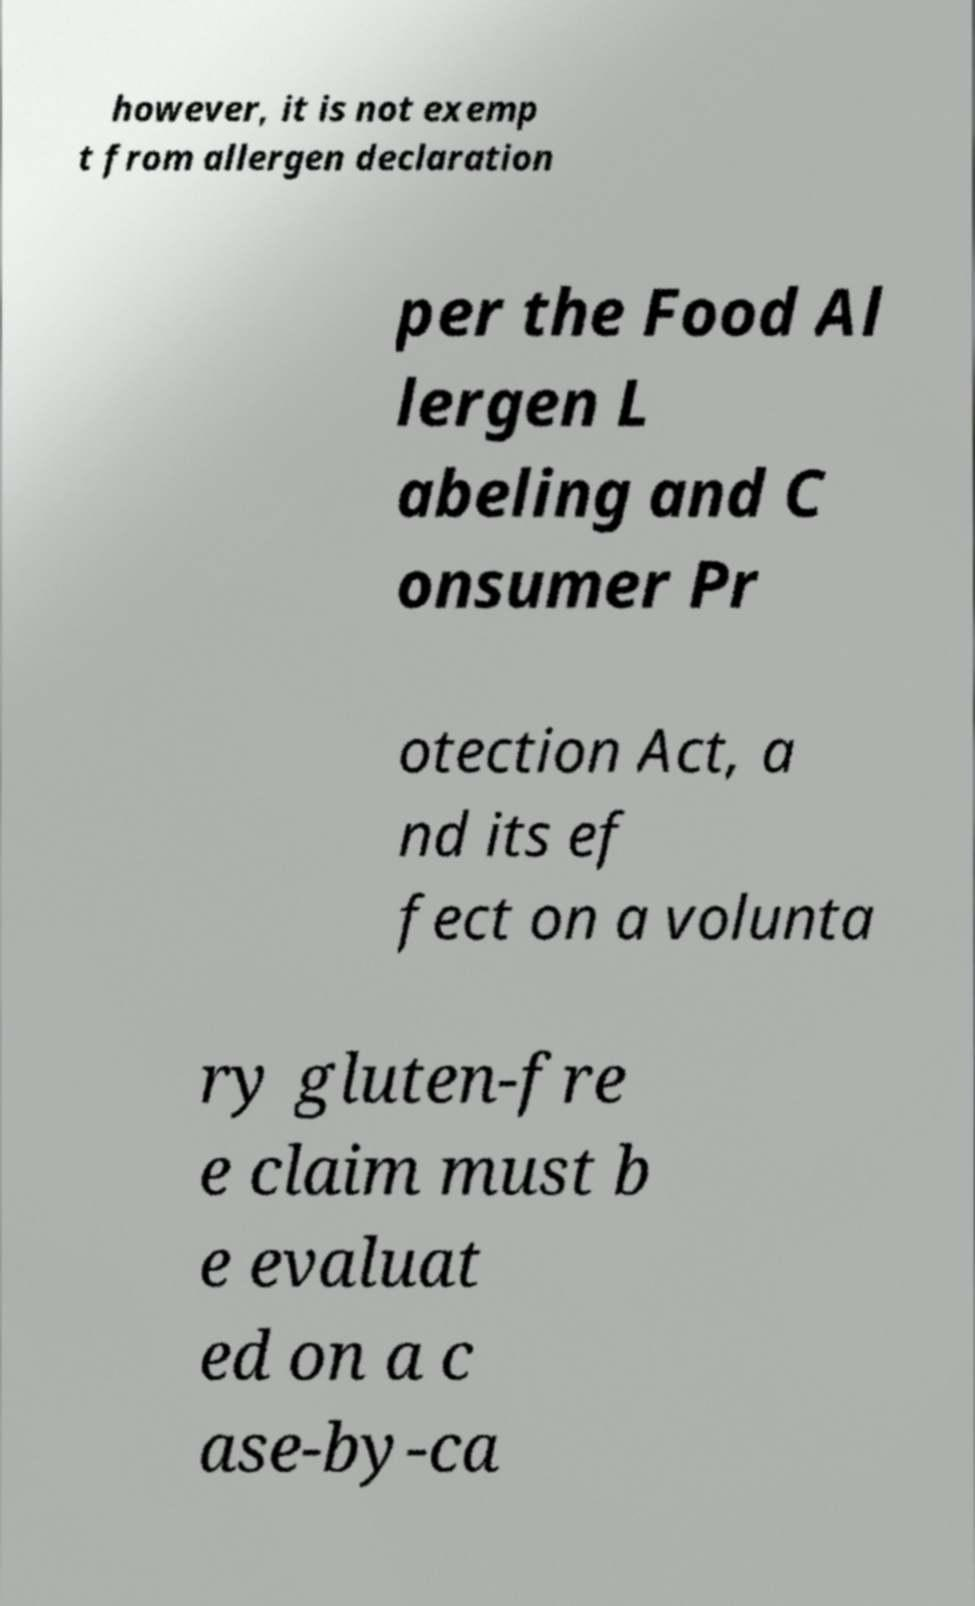What messages or text are displayed in this image? I need them in a readable, typed format. however, it is not exemp t from allergen declaration per the Food Al lergen L abeling and C onsumer Pr otection Act, a nd its ef fect on a volunta ry gluten-fre e claim must b e evaluat ed on a c ase-by-ca 